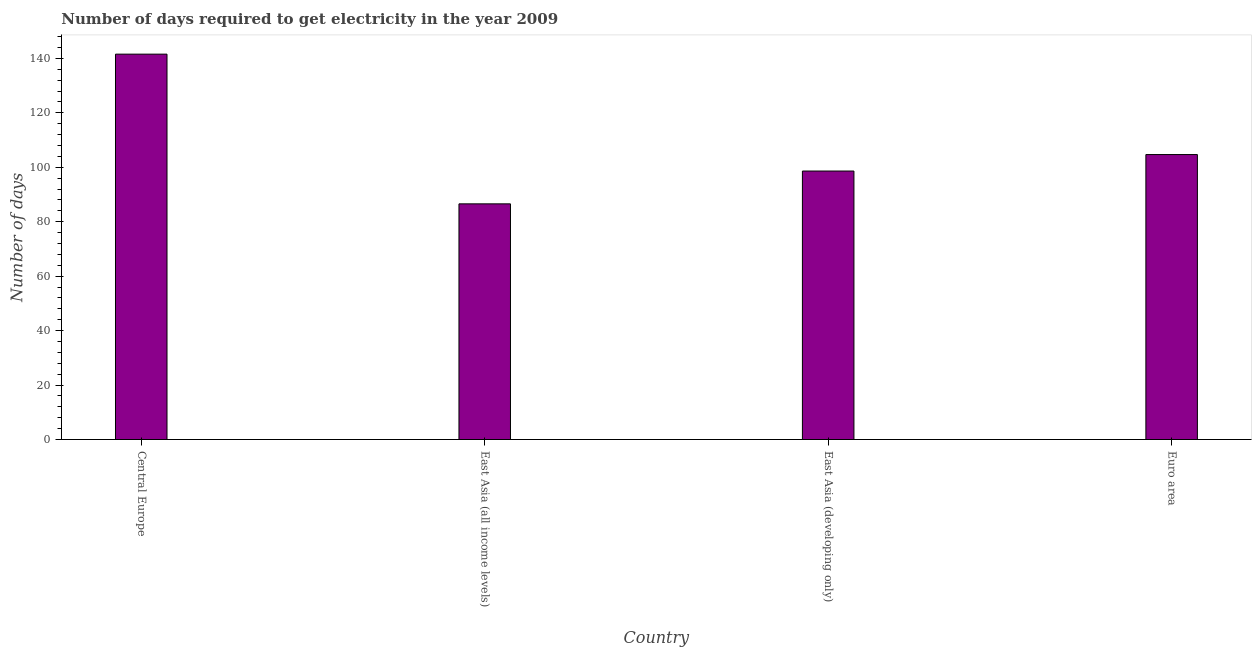Does the graph contain any zero values?
Offer a terse response. No. What is the title of the graph?
Give a very brief answer. Number of days required to get electricity in the year 2009. What is the label or title of the Y-axis?
Keep it short and to the point. Number of days. What is the time to get electricity in East Asia (developing only)?
Offer a very short reply. 98.61. Across all countries, what is the maximum time to get electricity?
Your answer should be compact. 141.55. Across all countries, what is the minimum time to get electricity?
Provide a succinct answer. 86.56. In which country was the time to get electricity maximum?
Offer a terse response. Central Europe. In which country was the time to get electricity minimum?
Provide a succinct answer. East Asia (all income levels). What is the sum of the time to get electricity?
Offer a very short reply. 431.38. What is the difference between the time to get electricity in East Asia (all income levels) and East Asia (developing only)?
Provide a succinct answer. -12.05. What is the average time to get electricity per country?
Give a very brief answer. 107.85. What is the median time to get electricity?
Give a very brief answer. 101.64. In how many countries, is the time to get electricity greater than 116 ?
Make the answer very short. 1. What is the ratio of the time to get electricity in Central Europe to that in Euro area?
Offer a very short reply. 1.35. Is the difference between the time to get electricity in Central Europe and East Asia (all income levels) greater than the difference between any two countries?
Offer a terse response. Yes. What is the difference between the highest and the second highest time to get electricity?
Make the answer very short. 36.88. Is the sum of the time to get electricity in Central Europe and East Asia (developing only) greater than the maximum time to get electricity across all countries?
Ensure brevity in your answer.  Yes. What is the difference between the highest and the lowest time to get electricity?
Your answer should be compact. 54.99. In how many countries, is the time to get electricity greater than the average time to get electricity taken over all countries?
Provide a short and direct response. 1. How many bars are there?
Offer a very short reply. 4. What is the Number of days of Central Europe?
Offer a terse response. 141.55. What is the Number of days in East Asia (all income levels)?
Your answer should be very brief. 86.56. What is the Number of days in East Asia (developing only)?
Ensure brevity in your answer.  98.61. What is the Number of days of Euro area?
Your answer should be very brief. 104.67. What is the difference between the Number of days in Central Europe and East Asia (all income levels)?
Give a very brief answer. 54.99. What is the difference between the Number of days in Central Europe and East Asia (developing only)?
Give a very brief answer. 42.93. What is the difference between the Number of days in Central Europe and Euro area?
Your response must be concise. 36.88. What is the difference between the Number of days in East Asia (all income levels) and East Asia (developing only)?
Offer a very short reply. -12.05. What is the difference between the Number of days in East Asia (all income levels) and Euro area?
Provide a short and direct response. -18.11. What is the difference between the Number of days in East Asia (developing only) and Euro area?
Your response must be concise. -6.06. What is the ratio of the Number of days in Central Europe to that in East Asia (all income levels)?
Offer a terse response. 1.64. What is the ratio of the Number of days in Central Europe to that in East Asia (developing only)?
Ensure brevity in your answer.  1.44. What is the ratio of the Number of days in Central Europe to that in Euro area?
Make the answer very short. 1.35. What is the ratio of the Number of days in East Asia (all income levels) to that in East Asia (developing only)?
Ensure brevity in your answer.  0.88. What is the ratio of the Number of days in East Asia (all income levels) to that in Euro area?
Keep it short and to the point. 0.83. What is the ratio of the Number of days in East Asia (developing only) to that in Euro area?
Provide a succinct answer. 0.94. 